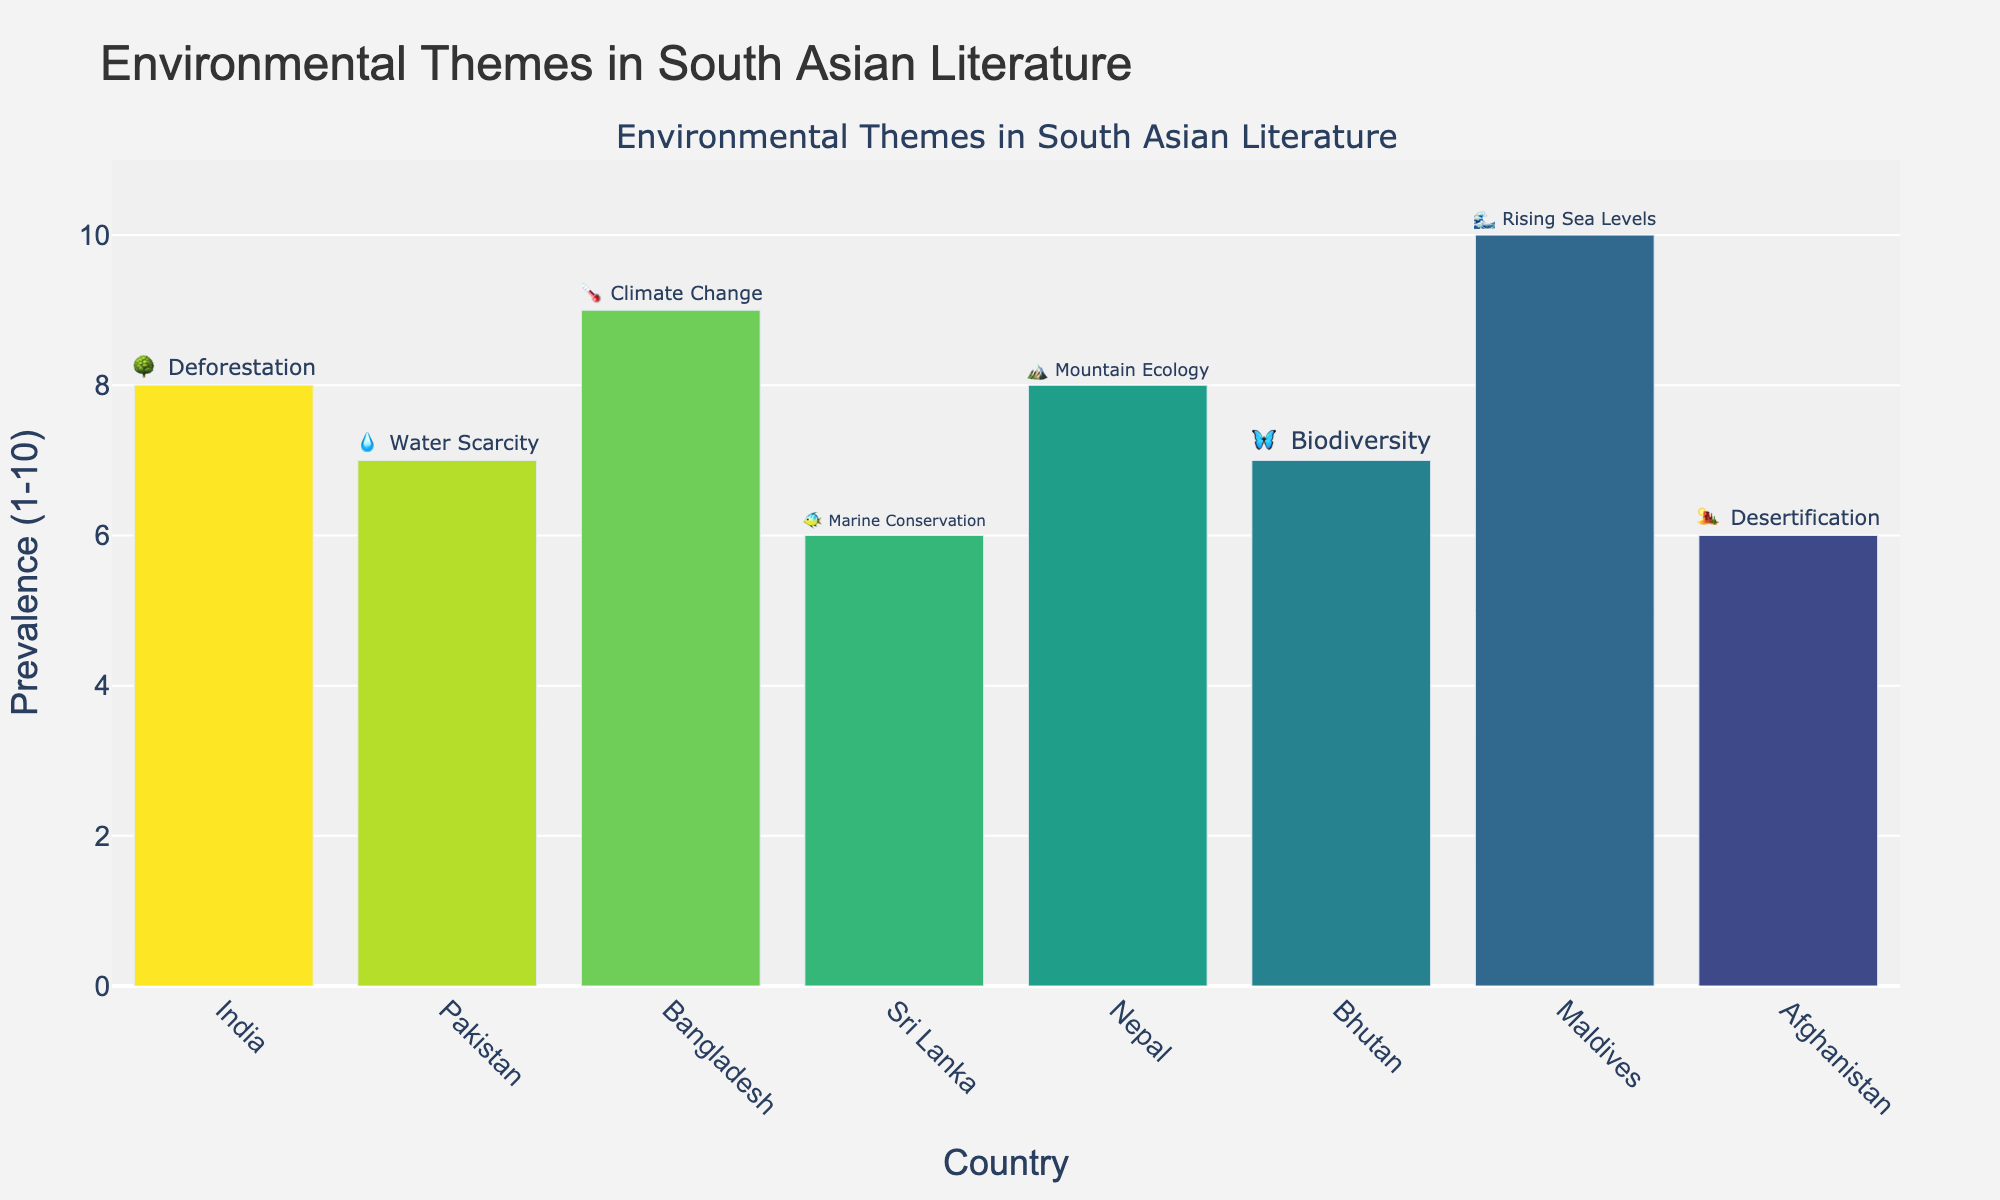what is the most prevalent environmental theme in the chart? The most prevalent theme is identified by the highest value on the y-axis. The highest prevalence is 10, associated with the Maldives' theme of Rising Sea Levels (🌊).
Answer: Rising Sea Levels (Maldives) Which country focuses on water scarcity? The chart includes a category for water scarcity. By examining the corresponding text and emoji above each bar, we find the entry for Pakistan with the theme of Water Scarcity (💧).
Answer: Pakistan Which two countries have the same prevalence score, and what is it? To find the countries with the same prevalence score, look for bars with identical heights. India and Nepal both have prevalence scores of 8 (🌳 and 🏔️, respectively).
Answer: India and Nepal (8) What is the average prevalence score across all countries? Add up all the prevalence scores and divide by the number of data points: (8+7+9+6+8+7+10+6)/8 = 61/8 = 7.625.
Answer: 7.625 Which theme has the highest prevalence in South Asian literature? The highest prevalence score is 10, related to the theme of Rising Sea Levels in the Maldives (🌊).
Answer: Rising Sea Levels How many countries have a prevalence score below 8? We count the bars with values under 8. Pakistan, Sri Lanka, Bhutan, and Afghanistan each have scores below 8 (7, 6, 7, 6 respectively).
Answer: 4 How much higher is the prevalence of Climate Change in Bangladesh compared to Marine Conservation in Sri Lanka? Subtract the prevalence of Marine Conservation from Climate Change: 9 (Climate Change) – 6 (Marine Conservation) = 3.
Answer: 3 Which country's environmental theme is biodiversity, and what is its prevalence score? By examining the corresponding text and emoji above each bar, Bhutan's theme is Biodiversity (🦋) with a prevalence score of 7.
Answer: Bhutan (7) Order the countries by prevalence in ascending order. List the countries by their prevalence scores: Afghanistan (6), Sri Lanka (6), Pakistan (7), Bhutan (7), India (8), Nepal (8), Bangladesh (9), and Maldives (10).
Answer: Afghanistan, Sri Lanka, Pakistan, Bhutan, India, Nepal, Bangladesh, Maldives What is the difference in prevalence score between the themes in Afghanistan and Bangladesh? Subtract the prevalence of Desertification (Afghanistan) from Climate Change (Bangladesh): 9 (Climate Change) – 6 (Desertification) = 3.
Answer: 3 